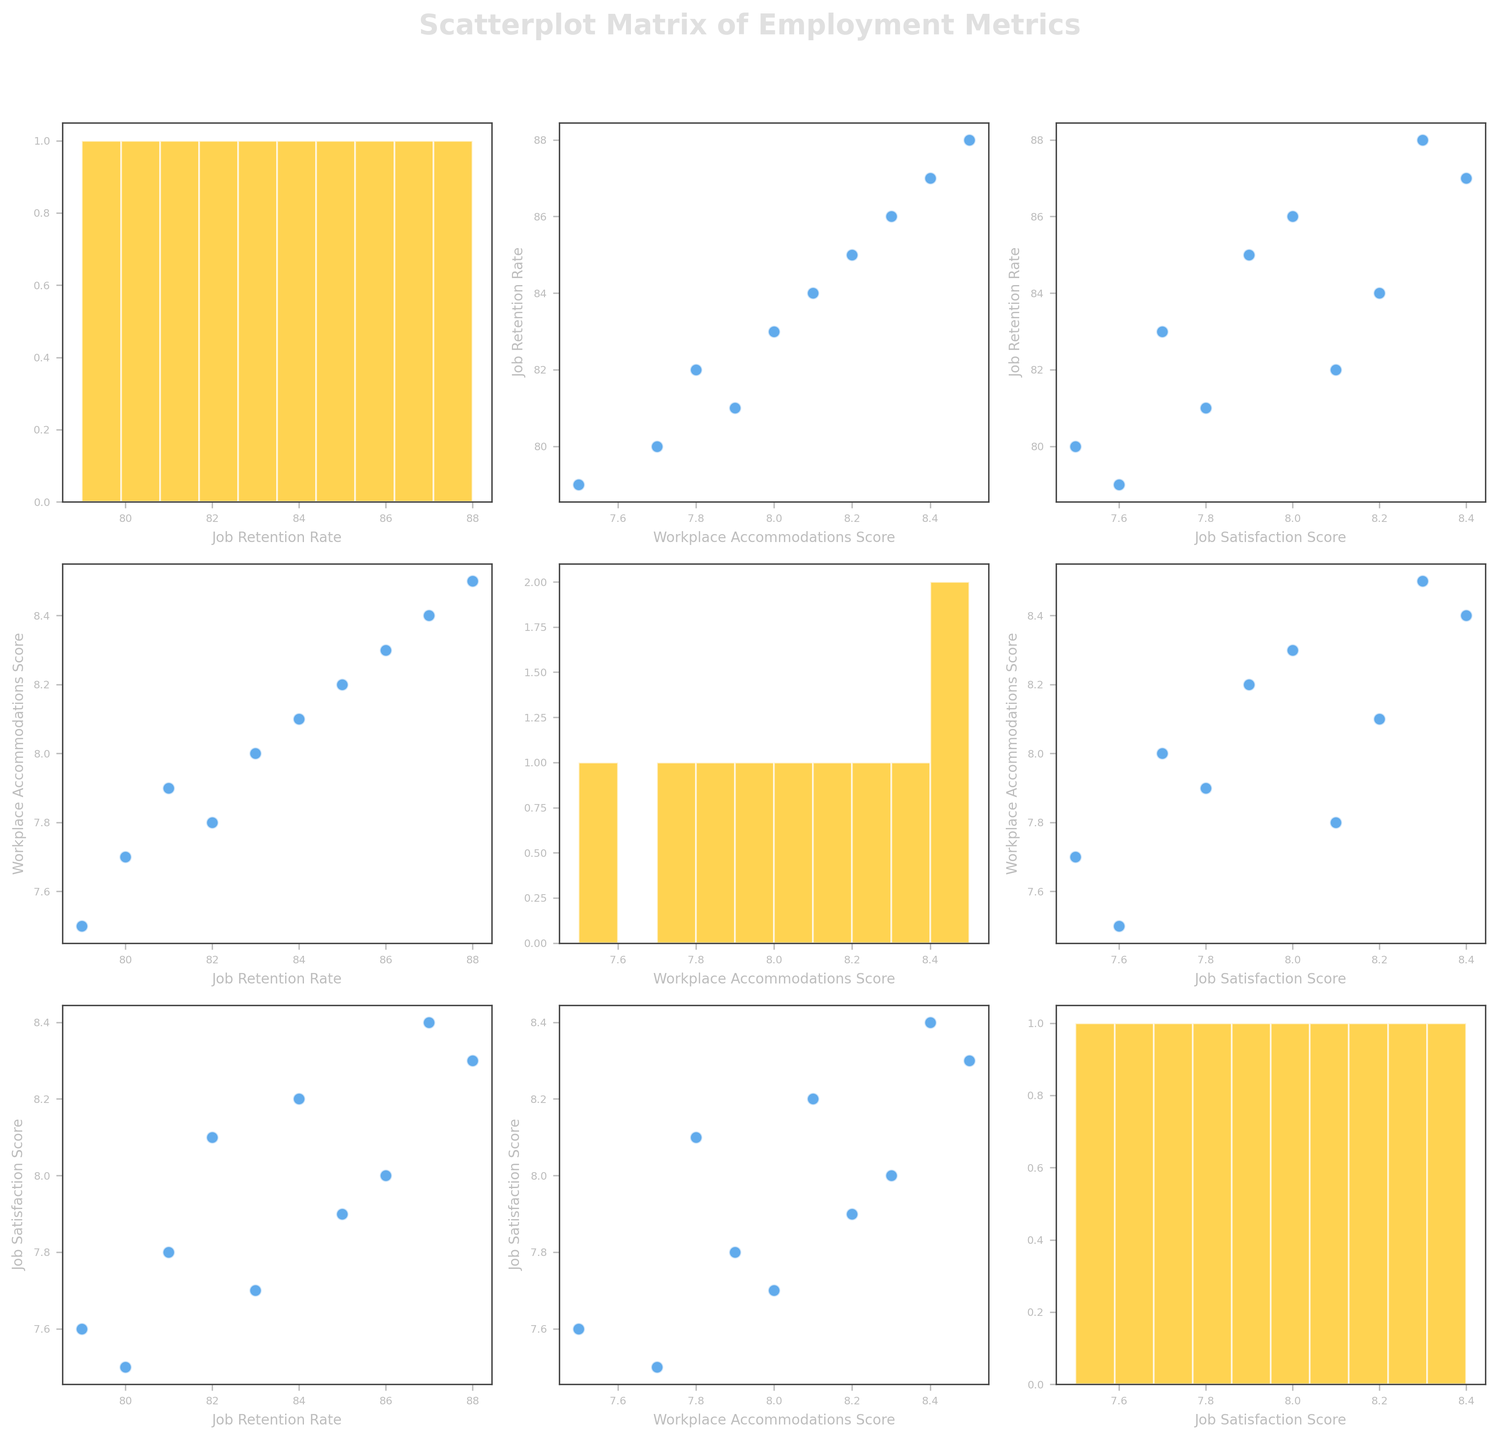What's the title of the figure? The title of the figure can be found at the top of the plot. It is clearly labeled.
Answer: Scatterplot Matrix of Employment Metrics What variables are used in the scatterplot matrix? The variables used in the scatterplot matrix are shown on the axes labels of the scatter plots and histograms within the figure. These variables are 'Job_Retention_Rate', 'Workplace_Accommodations_Score', and 'Job_Satisfaction_Score'.
Answer: Job_Retention_Rate, Workplace_Accommodations_Score, Job_Satisfaction_Score Which variable has the highest range of values in the scatterplot matrix? To determine the variable with the highest range of values, check the scales of the axes for each histogram. The variable with the widest span on its axis represents the highest range.
Answer: Job_Retention_Rate How many data points are represented in the scatter plots? The total number of data points can be counted from any of the scatter plots within the scatterplot matrix. All scatter plots should exhibit the same number of points.
Answer: 10 Which two variables appear to have the strongest positive correlation? To find the variables with the strongest positive correlation, observe the scatter plots where data points are closest to forming a straight line with a positive slope.
Answer: Job_Retention_Rate and Job_Satisfaction_Score Is there any variable pair that appears to show no clear correlation? Check the scatter plots to identify any pairs of variables where the data points are widely dispersed without forming a discernible pattern.
Answer: Workplace_Accommodations_Score and Job_Retention_Rate What can be said about the distribution of the 'Workplace_Accommodations_Score'? Inspect the histogram on the diagonal corresponding to 'Workplace_Accommodations_Score'. This will show the distribution of its values.
Answer: The distribution appears fairly even Which agency has the highest Job Satisfaction Score and what is its value? Examine the scatter plots or histograms for the 'Job_Satisfaction_Score' to find the point that lies the highest on the scale, and identify the corresponding agency.
Answer: Empower Employment, 8.4 Do any agencies have both high Job Retention Rates and high Job Satisfaction Scores? Look at the scatter plot that compares 'Job_Retention_Rate' and 'Job_Satisfaction_Score' to find points in the upper right quadrant indicating both high job retention and high job satisfaction. Empower Employment and Diverse Talent Solutions.
Answer: Empower Employment, Diverse Talent Solutions 